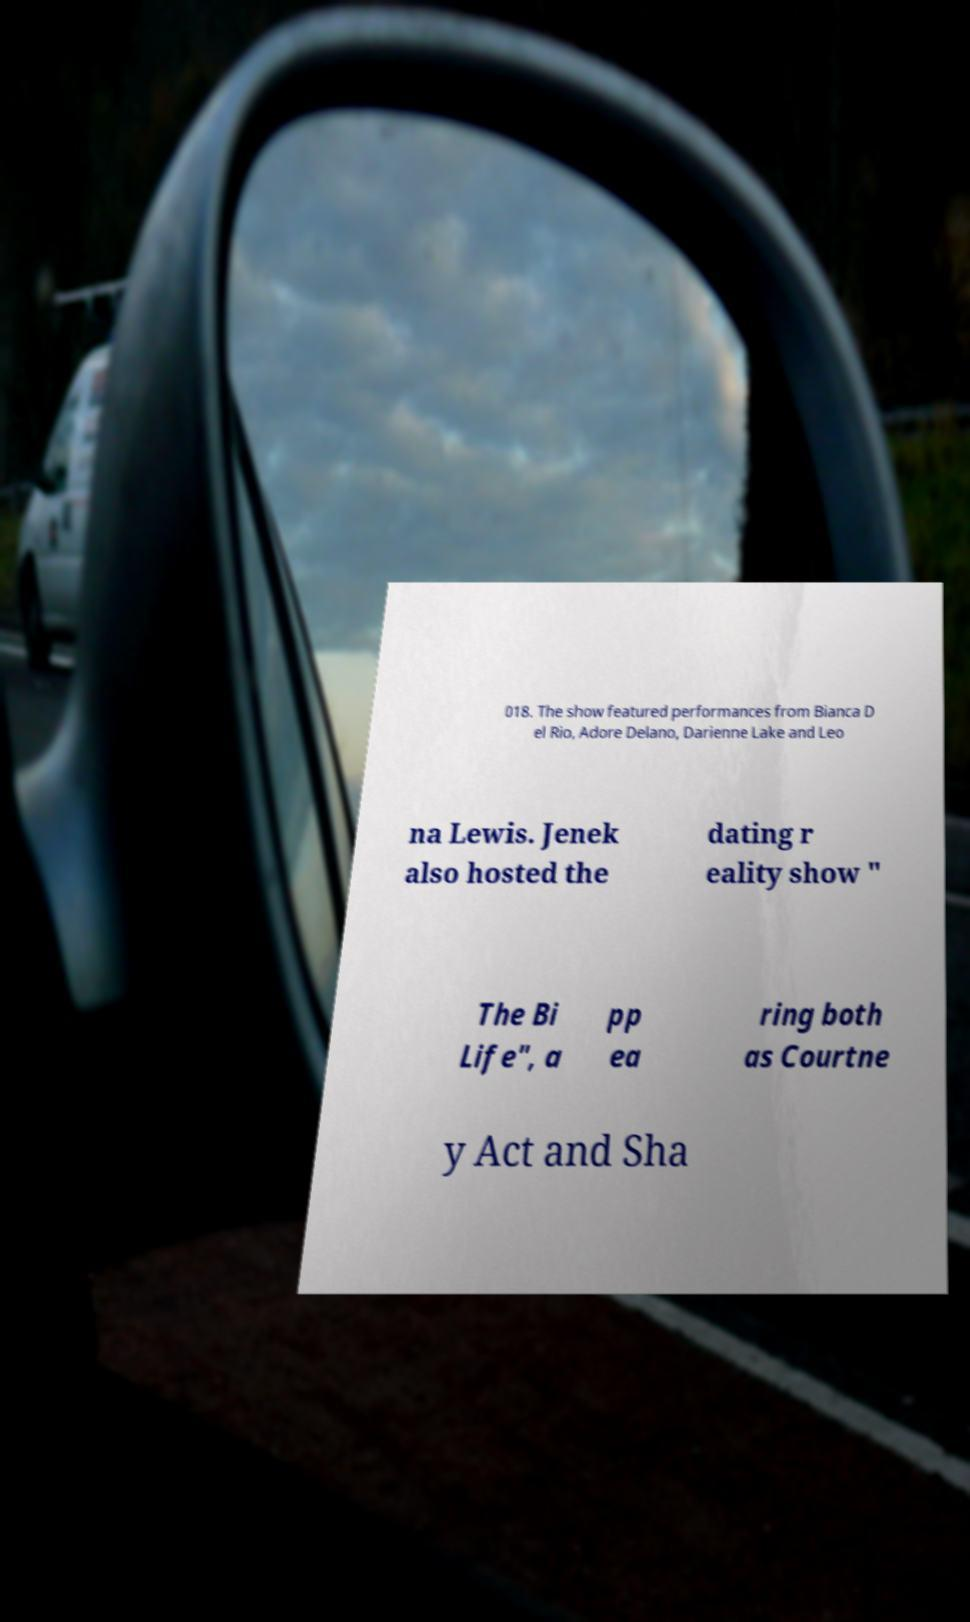There's text embedded in this image that I need extracted. Can you transcribe it verbatim? 018. The show featured performances from Bianca D el Rio, Adore Delano, Darienne Lake and Leo na Lewis. Jenek also hosted the dating r eality show " The Bi Life", a pp ea ring both as Courtne y Act and Sha 